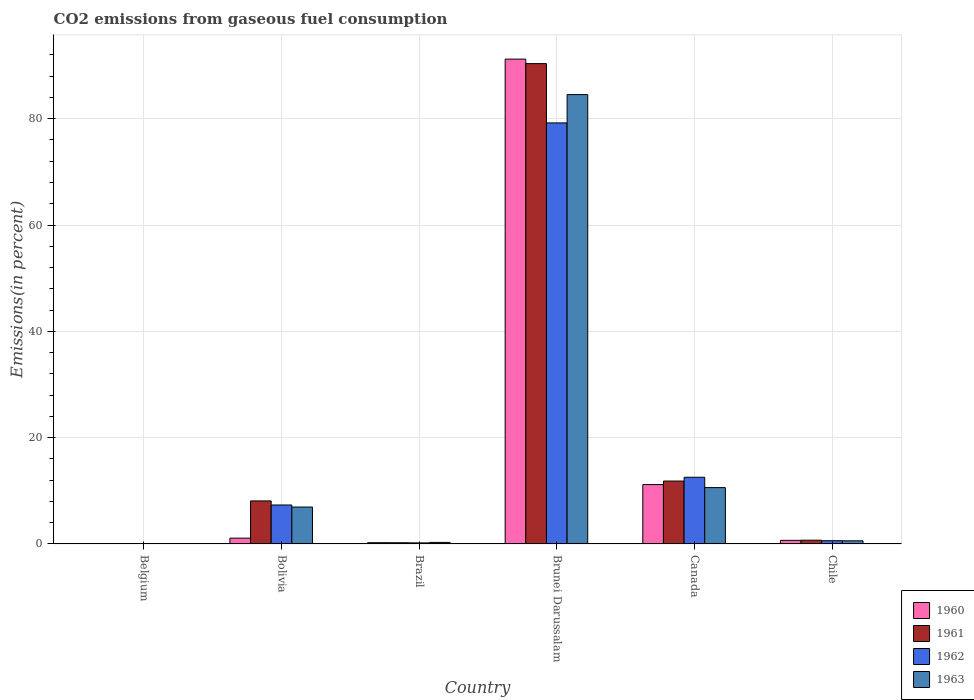Are the number of bars per tick equal to the number of legend labels?
Give a very brief answer. Yes. Are the number of bars on each tick of the X-axis equal?
Make the answer very short. Yes. How many bars are there on the 2nd tick from the left?
Provide a short and direct response. 4. What is the label of the 4th group of bars from the left?
Keep it short and to the point. Brunei Darussalam. What is the total CO2 emitted in 1963 in Belgium?
Keep it short and to the point. 0.07. Across all countries, what is the maximum total CO2 emitted in 1961?
Offer a very short reply. 90.36. Across all countries, what is the minimum total CO2 emitted in 1960?
Give a very brief answer. 0.07. In which country was the total CO2 emitted in 1960 maximum?
Provide a short and direct response. Brunei Darussalam. In which country was the total CO2 emitted in 1962 minimum?
Give a very brief answer. Belgium. What is the total total CO2 emitted in 1961 in the graph?
Make the answer very short. 111.31. What is the difference between the total CO2 emitted in 1961 in Bolivia and that in Canada?
Offer a very short reply. -3.74. What is the difference between the total CO2 emitted in 1961 in Bolivia and the total CO2 emitted in 1960 in Brazil?
Offer a very short reply. 7.86. What is the average total CO2 emitted in 1962 per country?
Your response must be concise. 16.66. What is the difference between the total CO2 emitted of/in 1963 and total CO2 emitted of/in 1961 in Canada?
Ensure brevity in your answer.  -1.23. What is the ratio of the total CO2 emitted in 1962 in Belgium to that in Brunei Darussalam?
Give a very brief answer. 0. Is the total CO2 emitted in 1960 in Bolivia less than that in Brunei Darussalam?
Make the answer very short. Yes. What is the difference between the highest and the second highest total CO2 emitted in 1962?
Provide a short and direct response. -5.22. What is the difference between the highest and the lowest total CO2 emitted in 1960?
Your response must be concise. 91.14. In how many countries, is the total CO2 emitted in 1963 greater than the average total CO2 emitted in 1963 taken over all countries?
Give a very brief answer. 1. What does the 3rd bar from the left in Bolivia represents?
Your answer should be compact. 1962. Is it the case that in every country, the sum of the total CO2 emitted in 1960 and total CO2 emitted in 1962 is greater than the total CO2 emitted in 1963?
Your answer should be very brief. Yes. How many bars are there?
Make the answer very short. 24. Are all the bars in the graph horizontal?
Offer a terse response. No. How many countries are there in the graph?
Provide a short and direct response. 6. What is the difference between two consecutive major ticks on the Y-axis?
Your response must be concise. 20. Are the values on the major ticks of Y-axis written in scientific E-notation?
Offer a terse response. No. Does the graph contain any zero values?
Give a very brief answer. No. What is the title of the graph?
Offer a terse response. CO2 emissions from gaseous fuel consumption. What is the label or title of the X-axis?
Keep it short and to the point. Country. What is the label or title of the Y-axis?
Offer a very short reply. Emissions(in percent). What is the Emissions(in percent) of 1960 in Belgium?
Your answer should be compact. 0.07. What is the Emissions(in percent) of 1961 in Belgium?
Offer a very short reply. 0.08. What is the Emissions(in percent) in 1962 in Belgium?
Your response must be concise. 0.08. What is the Emissions(in percent) of 1963 in Belgium?
Your response must be concise. 0.07. What is the Emissions(in percent) in 1960 in Bolivia?
Your response must be concise. 1.09. What is the Emissions(in percent) of 1961 in Bolivia?
Give a very brief answer. 8.1. What is the Emissions(in percent) in 1962 in Bolivia?
Offer a terse response. 7.33. What is the Emissions(in percent) in 1963 in Bolivia?
Provide a succinct answer. 6.95. What is the Emissions(in percent) in 1960 in Brazil?
Your answer should be very brief. 0.24. What is the Emissions(in percent) of 1961 in Brazil?
Your answer should be very brief. 0.23. What is the Emissions(in percent) of 1962 in Brazil?
Offer a terse response. 0.2. What is the Emissions(in percent) of 1963 in Brazil?
Make the answer very short. 0.3. What is the Emissions(in percent) in 1960 in Brunei Darussalam?
Your response must be concise. 91.21. What is the Emissions(in percent) of 1961 in Brunei Darussalam?
Your answer should be very brief. 90.36. What is the Emissions(in percent) in 1962 in Brunei Darussalam?
Provide a succinct answer. 79.21. What is the Emissions(in percent) in 1963 in Brunei Darussalam?
Keep it short and to the point. 84.54. What is the Emissions(in percent) in 1960 in Canada?
Offer a very short reply. 11.17. What is the Emissions(in percent) in 1961 in Canada?
Give a very brief answer. 11.84. What is the Emissions(in percent) of 1962 in Canada?
Offer a terse response. 12.55. What is the Emissions(in percent) of 1963 in Canada?
Your answer should be compact. 10.6. What is the Emissions(in percent) in 1960 in Chile?
Provide a succinct answer. 0.68. What is the Emissions(in percent) of 1961 in Chile?
Offer a terse response. 0.71. What is the Emissions(in percent) of 1962 in Chile?
Offer a terse response. 0.61. What is the Emissions(in percent) in 1963 in Chile?
Provide a succinct answer. 0.59. Across all countries, what is the maximum Emissions(in percent) of 1960?
Offer a very short reply. 91.21. Across all countries, what is the maximum Emissions(in percent) of 1961?
Provide a succinct answer. 90.36. Across all countries, what is the maximum Emissions(in percent) of 1962?
Your answer should be compact. 79.21. Across all countries, what is the maximum Emissions(in percent) of 1963?
Ensure brevity in your answer.  84.54. Across all countries, what is the minimum Emissions(in percent) in 1960?
Offer a terse response. 0.07. Across all countries, what is the minimum Emissions(in percent) of 1961?
Make the answer very short. 0.08. Across all countries, what is the minimum Emissions(in percent) of 1962?
Your answer should be very brief. 0.08. Across all countries, what is the minimum Emissions(in percent) in 1963?
Ensure brevity in your answer.  0.07. What is the total Emissions(in percent) in 1960 in the graph?
Keep it short and to the point. 104.47. What is the total Emissions(in percent) of 1961 in the graph?
Keep it short and to the point. 111.31. What is the total Emissions(in percent) of 1962 in the graph?
Your answer should be compact. 99.99. What is the total Emissions(in percent) in 1963 in the graph?
Keep it short and to the point. 103.04. What is the difference between the Emissions(in percent) in 1960 in Belgium and that in Bolivia?
Keep it short and to the point. -1.03. What is the difference between the Emissions(in percent) in 1961 in Belgium and that in Bolivia?
Offer a terse response. -8.02. What is the difference between the Emissions(in percent) of 1962 in Belgium and that in Bolivia?
Provide a succinct answer. -7.25. What is the difference between the Emissions(in percent) in 1963 in Belgium and that in Bolivia?
Offer a terse response. -6.88. What is the difference between the Emissions(in percent) in 1960 in Belgium and that in Brazil?
Ensure brevity in your answer.  -0.17. What is the difference between the Emissions(in percent) in 1961 in Belgium and that in Brazil?
Ensure brevity in your answer.  -0.16. What is the difference between the Emissions(in percent) in 1962 in Belgium and that in Brazil?
Make the answer very short. -0.13. What is the difference between the Emissions(in percent) in 1963 in Belgium and that in Brazil?
Offer a very short reply. -0.23. What is the difference between the Emissions(in percent) of 1960 in Belgium and that in Brunei Darussalam?
Provide a succinct answer. -91.14. What is the difference between the Emissions(in percent) of 1961 in Belgium and that in Brunei Darussalam?
Your answer should be very brief. -90.29. What is the difference between the Emissions(in percent) in 1962 in Belgium and that in Brunei Darussalam?
Provide a succinct answer. -79.13. What is the difference between the Emissions(in percent) in 1963 in Belgium and that in Brunei Darussalam?
Offer a terse response. -84.47. What is the difference between the Emissions(in percent) of 1960 in Belgium and that in Canada?
Offer a very short reply. -11.11. What is the difference between the Emissions(in percent) in 1961 in Belgium and that in Canada?
Your response must be concise. -11.76. What is the difference between the Emissions(in percent) of 1962 in Belgium and that in Canada?
Provide a succinct answer. -12.47. What is the difference between the Emissions(in percent) in 1963 in Belgium and that in Canada?
Give a very brief answer. -10.54. What is the difference between the Emissions(in percent) of 1960 in Belgium and that in Chile?
Provide a short and direct response. -0.61. What is the difference between the Emissions(in percent) of 1961 in Belgium and that in Chile?
Offer a very short reply. -0.63. What is the difference between the Emissions(in percent) of 1962 in Belgium and that in Chile?
Your response must be concise. -0.54. What is the difference between the Emissions(in percent) of 1963 in Belgium and that in Chile?
Your response must be concise. -0.53. What is the difference between the Emissions(in percent) in 1960 in Bolivia and that in Brazil?
Your answer should be compact. 0.85. What is the difference between the Emissions(in percent) of 1961 in Bolivia and that in Brazil?
Keep it short and to the point. 7.87. What is the difference between the Emissions(in percent) in 1962 in Bolivia and that in Brazil?
Provide a short and direct response. 7.13. What is the difference between the Emissions(in percent) of 1963 in Bolivia and that in Brazil?
Offer a terse response. 6.65. What is the difference between the Emissions(in percent) of 1960 in Bolivia and that in Brunei Darussalam?
Your response must be concise. -90.11. What is the difference between the Emissions(in percent) of 1961 in Bolivia and that in Brunei Darussalam?
Your answer should be compact. -82.26. What is the difference between the Emissions(in percent) in 1962 in Bolivia and that in Brunei Darussalam?
Make the answer very short. -71.87. What is the difference between the Emissions(in percent) of 1963 in Bolivia and that in Brunei Darussalam?
Your answer should be very brief. -77.59. What is the difference between the Emissions(in percent) in 1960 in Bolivia and that in Canada?
Offer a terse response. -10.08. What is the difference between the Emissions(in percent) of 1961 in Bolivia and that in Canada?
Make the answer very short. -3.74. What is the difference between the Emissions(in percent) of 1962 in Bolivia and that in Canada?
Your answer should be very brief. -5.22. What is the difference between the Emissions(in percent) of 1963 in Bolivia and that in Canada?
Make the answer very short. -3.65. What is the difference between the Emissions(in percent) in 1960 in Bolivia and that in Chile?
Ensure brevity in your answer.  0.42. What is the difference between the Emissions(in percent) of 1961 in Bolivia and that in Chile?
Offer a very short reply. 7.39. What is the difference between the Emissions(in percent) in 1962 in Bolivia and that in Chile?
Your answer should be compact. 6.72. What is the difference between the Emissions(in percent) of 1963 in Bolivia and that in Chile?
Your response must be concise. 6.36. What is the difference between the Emissions(in percent) of 1960 in Brazil and that in Brunei Darussalam?
Offer a very short reply. -90.97. What is the difference between the Emissions(in percent) of 1961 in Brazil and that in Brunei Darussalam?
Give a very brief answer. -90.13. What is the difference between the Emissions(in percent) in 1962 in Brazil and that in Brunei Darussalam?
Keep it short and to the point. -79. What is the difference between the Emissions(in percent) in 1963 in Brazil and that in Brunei Darussalam?
Your answer should be compact. -84.24. What is the difference between the Emissions(in percent) in 1960 in Brazil and that in Canada?
Provide a succinct answer. -10.93. What is the difference between the Emissions(in percent) of 1961 in Brazil and that in Canada?
Provide a succinct answer. -11.61. What is the difference between the Emissions(in percent) in 1962 in Brazil and that in Canada?
Offer a terse response. -12.34. What is the difference between the Emissions(in percent) in 1963 in Brazil and that in Canada?
Give a very brief answer. -10.31. What is the difference between the Emissions(in percent) in 1960 in Brazil and that in Chile?
Offer a very short reply. -0.44. What is the difference between the Emissions(in percent) of 1961 in Brazil and that in Chile?
Make the answer very short. -0.48. What is the difference between the Emissions(in percent) of 1962 in Brazil and that in Chile?
Your answer should be compact. -0.41. What is the difference between the Emissions(in percent) in 1963 in Brazil and that in Chile?
Ensure brevity in your answer.  -0.29. What is the difference between the Emissions(in percent) in 1960 in Brunei Darussalam and that in Canada?
Offer a terse response. 80.03. What is the difference between the Emissions(in percent) of 1961 in Brunei Darussalam and that in Canada?
Ensure brevity in your answer.  78.52. What is the difference between the Emissions(in percent) of 1962 in Brunei Darussalam and that in Canada?
Give a very brief answer. 66.66. What is the difference between the Emissions(in percent) of 1963 in Brunei Darussalam and that in Canada?
Make the answer very short. 73.93. What is the difference between the Emissions(in percent) of 1960 in Brunei Darussalam and that in Chile?
Provide a short and direct response. 90.53. What is the difference between the Emissions(in percent) of 1961 in Brunei Darussalam and that in Chile?
Provide a succinct answer. 89.65. What is the difference between the Emissions(in percent) of 1962 in Brunei Darussalam and that in Chile?
Keep it short and to the point. 78.59. What is the difference between the Emissions(in percent) of 1963 in Brunei Darussalam and that in Chile?
Offer a very short reply. 83.94. What is the difference between the Emissions(in percent) of 1960 in Canada and that in Chile?
Keep it short and to the point. 10.49. What is the difference between the Emissions(in percent) of 1961 in Canada and that in Chile?
Offer a terse response. 11.13. What is the difference between the Emissions(in percent) in 1962 in Canada and that in Chile?
Your response must be concise. 11.93. What is the difference between the Emissions(in percent) in 1963 in Canada and that in Chile?
Offer a terse response. 10.01. What is the difference between the Emissions(in percent) in 1960 in Belgium and the Emissions(in percent) in 1961 in Bolivia?
Offer a very short reply. -8.03. What is the difference between the Emissions(in percent) in 1960 in Belgium and the Emissions(in percent) in 1962 in Bolivia?
Make the answer very short. -7.26. What is the difference between the Emissions(in percent) of 1960 in Belgium and the Emissions(in percent) of 1963 in Bolivia?
Make the answer very short. -6.88. What is the difference between the Emissions(in percent) in 1961 in Belgium and the Emissions(in percent) in 1962 in Bolivia?
Give a very brief answer. -7.26. What is the difference between the Emissions(in percent) in 1961 in Belgium and the Emissions(in percent) in 1963 in Bolivia?
Your response must be concise. -6.87. What is the difference between the Emissions(in percent) in 1962 in Belgium and the Emissions(in percent) in 1963 in Bolivia?
Make the answer very short. -6.87. What is the difference between the Emissions(in percent) of 1960 in Belgium and the Emissions(in percent) of 1961 in Brazil?
Your answer should be very brief. -0.16. What is the difference between the Emissions(in percent) in 1960 in Belgium and the Emissions(in percent) in 1962 in Brazil?
Provide a short and direct response. -0.14. What is the difference between the Emissions(in percent) in 1960 in Belgium and the Emissions(in percent) in 1963 in Brazil?
Ensure brevity in your answer.  -0.23. What is the difference between the Emissions(in percent) of 1961 in Belgium and the Emissions(in percent) of 1962 in Brazil?
Provide a short and direct response. -0.13. What is the difference between the Emissions(in percent) of 1961 in Belgium and the Emissions(in percent) of 1963 in Brazil?
Offer a very short reply. -0.22. What is the difference between the Emissions(in percent) in 1962 in Belgium and the Emissions(in percent) in 1963 in Brazil?
Keep it short and to the point. -0.22. What is the difference between the Emissions(in percent) in 1960 in Belgium and the Emissions(in percent) in 1961 in Brunei Darussalam?
Provide a short and direct response. -90.29. What is the difference between the Emissions(in percent) of 1960 in Belgium and the Emissions(in percent) of 1962 in Brunei Darussalam?
Give a very brief answer. -79.14. What is the difference between the Emissions(in percent) in 1960 in Belgium and the Emissions(in percent) in 1963 in Brunei Darussalam?
Provide a short and direct response. -84.47. What is the difference between the Emissions(in percent) in 1961 in Belgium and the Emissions(in percent) in 1962 in Brunei Darussalam?
Ensure brevity in your answer.  -79.13. What is the difference between the Emissions(in percent) of 1961 in Belgium and the Emissions(in percent) of 1963 in Brunei Darussalam?
Provide a succinct answer. -84.46. What is the difference between the Emissions(in percent) in 1962 in Belgium and the Emissions(in percent) in 1963 in Brunei Darussalam?
Offer a terse response. -84.46. What is the difference between the Emissions(in percent) of 1960 in Belgium and the Emissions(in percent) of 1961 in Canada?
Keep it short and to the point. -11.77. What is the difference between the Emissions(in percent) of 1960 in Belgium and the Emissions(in percent) of 1962 in Canada?
Your answer should be compact. -12.48. What is the difference between the Emissions(in percent) of 1960 in Belgium and the Emissions(in percent) of 1963 in Canada?
Your response must be concise. -10.53. What is the difference between the Emissions(in percent) of 1961 in Belgium and the Emissions(in percent) of 1962 in Canada?
Offer a terse response. -12.47. What is the difference between the Emissions(in percent) in 1961 in Belgium and the Emissions(in percent) in 1963 in Canada?
Keep it short and to the point. -10.53. What is the difference between the Emissions(in percent) in 1962 in Belgium and the Emissions(in percent) in 1963 in Canada?
Give a very brief answer. -10.52. What is the difference between the Emissions(in percent) in 1960 in Belgium and the Emissions(in percent) in 1961 in Chile?
Ensure brevity in your answer.  -0.64. What is the difference between the Emissions(in percent) of 1960 in Belgium and the Emissions(in percent) of 1962 in Chile?
Offer a terse response. -0.55. What is the difference between the Emissions(in percent) of 1960 in Belgium and the Emissions(in percent) of 1963 in Chile?
Offer a very short reply. -0.52. What is the difference between the Emissions(in percent) in 1961 in Belgium and the Emissions(in percent) in 1962 in Chile?
Ensure brevity in your answer.  -0.54. What is the difference between the Emissions(in percent) of 1961 in Belgium and the Emissions(in percent) of 1963 in Chile?
Offer a terse response. -0.52. What is the difference between the Emissions(in percent) in 1962 in Belgium and the Emissions(in percent) in 1963 in Chile?
Keep it short and to the point. -0.51. What is the difference between the Emissions(in percent) of 1960 in Bolivia and the Emissions(in percent) of 1961 in Brazil?
Your answer should be compact. 0.86. What is the difference between the Emissions(in percent) in 1960 in Bolivia and the Emissions(in percent) in 1962 in Brazil?
Give a very brief answer. 0.89. What is the difference between the Emissions(in percent) in 1960 in Bolivia and the Emissions(in percent) in 1963 in Brazil?
Give a very brief answer. 0.8. What is the difference between the Emissions(in percent) of 1961 in Bolivia and the Emissions(in percent) of 1962 in Brazil?
Ensure brevity in your answer.  7.89. What is the difference between the Emissions(in percent) in 1961 in Bolivia and the Emissions(in percent) in 1963 in Brazil?
Ensure brevity in your answer.  7.8. What is the difference between the Emissions(in percent) in 1962 in Bolivia and the Emissions(in percent) in 1963 in Brazil?
Provide a succinct answer. 7.04. What is the difference between the Emissions(in percent) of 1960 in Bolivia and the Emissions(in percent) of 1961 in Brunei Darussalam?
Keep it short and to the point. -89.27. What is the difference between the Emissions(in percent) in 1960 in Bolivia and the Emissions(in percent) in 1962 in Brunei Darussalam?
Provide a succinct answer. -78.11. What is the difference between the Emissions(in percent) of 1960 in Bolivia and the Emissions(in percent) of 1963 in Brunei Darussalam?
Your answer should be very brief. -83.44. What is the difference between the Emissions(in percent) of 1961 in Bolivia and the Emissions(in percent) of 1962 in Brunei Darussalam?
Your response must be concise. -71.11. What is the difference between the Emissions(in percent) in 1961 in Bolivia and the Emissions(in percent) in 1963 in Brunei Darussalam?
Offer a very short reply. -76.44. What is the difference between the Emissions(in percent) of 1962 in Bolivia and the Emissions(in percent) of 1963 in Brunei Darussalam?
Your answer should be very brief. -77.2. What is the difference between the Emissions(in percent) in 1960 in Bolivia and the Emissions(in percent) in 1961 in Canada?
Your answer should be very brief. -10.74. What is the difference between the Emissions(in percent) of 1960 in Bolivia and the Emissions(in percent) of 1962 in Canada?
Make the answer very short. -11.45. What is the difference between the Emissions(in percent) in 1960 in Bolivia and the Emissions(in percent) in 1963 in Canada?
Provide a short and direct response. -9.51. What is the difference between the Emissions(in percent) of 1961 in Bolivia and the Emissions(in percent) of 1962 in Canada?
Your answer should be very brief. -4.45. What is the difference between the Emissions(in percent) in 1961 in Bolivia and the Emissions(in percent) in 1963 in Canada?
Offer a terse response. -2.5. What is the difference between the Emissions(in percent) in 1962 in Bolivia and the Emissions(in percent) in 1963 in Canada?
Keep it short and to the point. -3.27. What is the difference between the Emissions(in percent) of 1960 in Bolivia and the Emissions(in percent) of 1961 in Chile?
Give a very brief answer. 0.39. What is the difference between the Emissions(in percent) in 1960 in Bolivia and the Emissions(in percent) in 1962 in Chile?
Give a very brief answer. 0.48. What is the difference between the Emissions(in percent) of 1960 in Bolivia and the Emissions(in percent) of 1963 in Chile?
Ensure brevity in your answer.  0.5. What is the difference between the Emissions(in percent) in 1961 in Bolivia and the Emissions(in percent) in 1962 in Chile?
Keep it short and to the point. 7.48. What is the difference between the Emissions(in percent) in 1961 in Bolivia and the Emissions(in percent) in 1963 in Chile?
Your answer should be compact. 7.51. What is the difference between the Emissions(in percent) of 1962 in Bolivia and the Emissions(in percent) of 1963 in Chile?
Keep it short and to the point. 6.74. What is the difference between the Emissions(in percent) in 1960 in Brazil and the Emissions(in percent) in 1961 in Brunei Darussalam?
Your response must be concise. -90.12. What is the difference between the Emissions(in percent) of 1960 in Brazil and the Emissions(in percent) of 1962 in Brunei Darussalam?
Give a very brief answer. -78.97. What is the difference between the Emissions(in percent) in 1960 in Brazil and the Emissions(in percent) in 1963 in Brunei Darussalam?
Offer a very short reply. -84.29. What is the difference between the Emissions(in percent) of 1961 in Brazil and the Emissions(in percent) of 1962 in Brunei Darussalam?
Provide a short and direct response. -78.98. What is the difference between the Emissions(in percent) of 1961 in Brazil and the Emissions(in percent) of 1963 in Brunei Darussalam?
Your response must be concise. -84.31. What is the difference between the Emissions(in percent) in 1962 in Brazil and the Emissions(in percent) in 1963 in Brunei Darussalam?
Keep it short and to the point. -84.33. What is the difference between the Emissions(in percent) in 1960 in Brazil and the Emissions(in percent) in 1961 in Canada?
Your answer should be compact. -11.59. What is the difference between the Emissions(in percent) of 1960 in Brazil and the Emissions(in percent) of 1962 in Canada?
Provide a succinct answer. -12.31. What is the difference between the Emissions(in percent) of 1960 in Brazil and the Emissions(in percent) of 1963 in Canada?
Your response must be concise. -10.36. What is the difference between the Emissions(in percent) in 1961 in Brazil and the Emissions(in percent) in 1962 in Canada?
Your response must be concise. -12.32. What is the difference between the Emissions(in percent) in 1961 in Brazil and the Emissions(in percent) in 1963 in Canada?
Provide a short and direct response. -10.37. What is the difference between the Emissions(in percent) in 1962 in Brazil and the Emissions(in percent) in 1963 in Canada?
Your answer should be very brief. -10.4. What is the difference between the Emissions(in percent) in 1960 in Brazil and the Emissions(in percent) in 1961 in Chile?
Give a very brief answer. -0.47. What is the difference between the Emissions(in percent) of 1960 in Brazil and the Emissions(in percent) of 1962 in Chile?
Provide a succinct answer. -0.37. What is the difference between the Emissions(in percent) of 1960 in Brazil and the Emissions(in percent) of 1963 in Chile?
Provide a succinct answer. -0.35. What is the difference between the Emissions(in percent) in 1961 in Brazil and the Emissions(in percent) in 1962 in Chile?
Make the answer very short. -0.38. What is the difference between the Emissions(in percent) in 1961 in Brazil and the Emissions(in percent) in 1963 in Chile?
Your response must be concise. -0.36. What is the difference between the Emissions(in percent) in 1962 in Brazil and the Emissions(in percent) in 1963 in Chile?
Keep it short and to the point. -0.39. What is the difference between the Emissions(in percent) in 1960 in Brunei Darussalam and the Emissions(in percent) in 1961 in Canada?
Provide a short and direct response. 79.37. What is the difference between the Emissions(in percent) in 1960 in Brunei Darussalam and the Emissions(in percent) in 1962 in Canada?
Your response must be concise. 78.66. What is the difference between the Emissions(in percent) of 1960 in Brunei Darussalam and the Emissions(in percent) of 1963 in Canada?
Offer a terse response. 80.61. What is the difference between the Emissions(in percent) of 1961 in Brunei Darussalam and the Emissions(in percent) of 1962 in Canada?
Offer a very short reply. 77.81. What is the difference between the Emissions(in percent) in 1961 in Brunei Darussalam and the Emissions(in percent) in 1963 in Canada?
Provide a succinct answer. 79.76. What is the difference between the Emissions(in percent) of 1962 in Brunei Darussalam and the Emissions(in percent) of 1963 in Canada?
Keep it short and to the point. 68.61. What is the difference between the Emissions(in percent) of 1960 in Brunei Darussalam and the Emissions(in percent) of 1961 in Chile?
Offer a terse response. 90.5. What is the difference between the Emissions(in percent) in 1960 in Brunei Darussalam and the Emissions(in percent) in 1962 in Chile?
Offer a very short reply. 90.59. What is the difference between the Emissions(in percent) in 1960 in Brunei Darussalam and the Emissions(in percent) in 1963 in Chile?
Your answer should be very brief. 90.62. What is the difference between the Emissions(in percent) of 1961 in Brunei Darussalam and the Emissions(in percent) of 1962 in Chile?
Your response must be concise. 89.75. What is the difference between the Emissions(in percent) in 1961 in Brunei Darussalam and the Emissions(in percent) in 1963 in Chile?
Ensure brevity in your answer.  89.77. What is the difference between the Emissions(in percent) in 1962 in Brunei Darussalam and the Emissions(in percent) in 1963 in Chile?
Offer a very short reply. 78.62. What is the difference between the Emissions(in percent) in 1960 in Canada and the Emissions(in percent) in 1961 in Chile?
Provide a short and direct response. 10.46. What is the difference between the Emissions(in percent) in 1960 in Canada and the Emissions(in percent) in 1962 in Chile?
Keep it short and to the point. 10.56. What is the difference between the Emissions(in percent) of 1960 in Canada and the Emissions(in percent) of 1963 in Chile?
Offer a very short reply. 10.58. What is the difference between the Emissions(in percent) in 1961 in Canada and the Emissions(in percent) in 1962 in Chile?
Your answer should be compact. 11.22. What is the difference between the Emissions(in percent) in 1961 in Canada and the Emissions(in percent) in 1963 in Chile?
Your answer should be compact. 11.25. What is the difference between the Emissions(in percent) in 1962 in Canada and the Emissions(in percent) in 1963 in Chile?
Make the answer very short. 11.96. What is the average Emissions(in percent) in 1960 per country?
Your response must be concise. 17.41. What is the average Emissions(in percent) in 1961 per country?
Provide a short and direct response. 18.55. What is the average Emissions(in percent) of 1962 per country?
Make the answer very short. 16.66. What is the average Emissions(in percent) in 1963 per country?
Offer a terse response. 17.17. What is the difference between the Emissions(in percent) of 1960 and Emissions(in percent) of 1961 in Belgium?
Offer a terse response. -0.01. What is the difference between the Emissions(in percent) of 1960 and Emissions(in percent) of 1962 in Belgium?
Offer a very short reply. -0.01. What is the difference between the Emissions(in percent) of 1960 and Emissions(in percent) of 1963 in Belgium?
Provide a short and direct response. 0. What is the difference between the Emissions(in percent) of 1961 and Emissions(in percent) of 1962 in Belgium?
Your answer should be compact. -0. What is the difference between the Emissions(in percent) in 1961 and Emissions(in percent) in 1963 in Belgium?
Ensure brevity in your answer.  0.01. What is the difference between the Emissions(in percent) of 1962 and Emissions(in percent) of 1963 in Belgium?
Your answer should be compact. 0.01. What is the difference between the Emissions(in percent) in 1960 and Emissions(in percent) in 1961 in Bolivia?
Give a very brief answer. -7. What is the difference between the Emissions(in percent) of 1960 and Emissions(in percent) of 1962 in Bolivia?
Make the answer very short. -6.24. What is the difference between the Emissions(in percent) of 1960 and Emissions(in percent) of 1963 in Bolivia?
Keep it short and to the point. -5.85. What is the difference between the Emissions(in percent) of 1961 and Emissions(in percent) of 1962 in Bolivia?
Provide a short and direct response. 0.77. What is the difference between the Emissions(in percent) of 1961 and Emissions(in percent) of 1963 in Bolivia?
Provide a short and direct response. 1.15. What is the difference between the Emissions(in percent) of 1962 and Emissions(in percent) of 1963 in Bolivia?
Offer a terse response. 0.38. What is the difference between the Emissions(in percent) in 1960 and Emissions(in percent) in 1961 in Brazil?
Offer a very short reply. 0.01. What is the difference between the Emissions(in percent) of 1960 and Emissions(in percent) of 1962 in Brazil?
Make the answer very short. 0.04. What is the difference between the Emissions(in percent) in 1960 and Emissions(in percent) in 1963 in Brazil?
Give a very brief answer. -0.05. What is the difference between the Emissions(in percent) of 1961 and Emissions(in percent) of 1962 in Brazil?
Your answer should be very brief. 0.03. What is the difference between the Emissions(in percent) of 1961 and Emissions(in percent) of 1963 in Brazil?
Ensure brevity in your answer.  -0.07. What is the difference between the Emissions(in percent) of 1962 and Emissions(in percent) of 1963 in Brazil?
Provide a short and direct response. -0.09. What is the difference between the Emissions(in percent) in 1960 and Emissions(in percent) in 1961 in Brunei Darussalam?
Give a very brief answer. 0.85. What is the difference between the Emissions(in percent) in 1960 and Emissions(in percent) in 1962 in Brunei Darussalam?
Provide a succinct answer. 12. What is the difference between the Emissions(in percent) in 1960 and Emissions(in percent) in 1963 in Brunei Darussalam?
Give a very brief answer. 6.67. What is the difference between the Emissions(in percent) in 1961 and Emissions(in percent) in 1962 in Brunei Darussalam?
Your answer should be very brief. 11.15. What is the difference between the Emissions(in percent) of 1961 and Emissions(in percent) of 1963 in Brunei Darussalam?
Make the answer very short. 5.83. What is the difference between the Emissions(in percent) of 1962 and Emissions(in percent) of 1963 in Brunei Darussalam?
Make the answer very short. -5.33. What is the difference between the Emissions(in percent) in 1960 and Emissions(in percent) in 1961 in Canada?
Offer a very short reply. -0.66. What is the difference between the Emissions(in percent) of 1960 and Emissions(in percent) of 1962 in Canada?
Your answer should be compact. -1.37. What is the difference between the Emissions(in percent) in 1960 and Emissions(in percent) in 1963 in Canada?
Your response must be concise. 0.57. What is the difference between the Emissions(in percent) in 1961 and Emissions(in percent) in 1962 in Canada?
Keep it short and to the point. -0.71. What is the difference between the Emissions(in percent) of 1961 and Emissions(in percent) of 1963 in Canada?
Give a very brief answer. 1.23. What is the difference between the Emissions(in percent) in 1962 and Emissions(in percent) in 1963 in Canada?
Provide a short and direct response. 1.95. What is the difference between the Emissions(in percent) in 1960 and Emissions(in percent) in 1961 in Chile?
Your answer should be compact. -0.03. What is the difference between the Emissions(in percent) in 1960 and Emissions(in percent) in 1962 in Chile?
Your answer should be compact. 0.07. What is the difference between the Emissions(in percent) in 1960 and Emissions(in percent) in 1963 in Chile?
Your answer should be compact. 0.09. What is the difference between the Emissions(in percent) in 1961 and Emissions(in percent) in 1962 in Chile?
Offer a terse response. 0.1. What is the difference between the Emissions(in percent) in 1961 and Emissions(in percent) in 1963 in Chile?
Your answer should be compact. 0.12. What is the difference between the Emissions(in percent) in 1962 and Emissions(in percent) in 1963 in Chile?
Keep it short and to the point. 0.02. What is the ratio of the Emissions(in percent) in 1960 in Belgium to that in Bolivia?
Keep it short and to the point. 0.06. What is the ratio of the Emissions(in percent) in 1961 in Belgium to that in Bolivia?
Your response must be concise. 0.01. What is the ratio of the Emissions(in percent) of 1962 in Belgium to that in Bolivia?
Your answer should be compact. 0.01. What is the ratio of the Emissions(in percent) of 1963 in Belgium to that in Bolivia?
Your answer should be compact. 0.01. What is the ratio of the Emissions(in percent) in 1960 in Belgium to that in Brazil?
Your answer should be very brief. 0.28. What is the ratio of the Emissions(in percent) of 1961 in Belgium to that in Brazil?
Provide a short and direct response. 0.33. What is the ratio of the Emissions(in percent) in 1962 in Belgium to that in Brazil?
Your answer should be very brief. 0.38. What is the ratio of the Emissions(in percent) in 1963 in Belgium to that in Brazil?
Give a very brief answer. 0.22. What is the ratio of the Emissions(in percent) in 1960 in Belgium to that in Brunei Darussalam?
Your answer should be very brief. 0. What is the ratio of the Emissions(in percent) in 1961 in Belgium to that in Brunei Darussalam?
Your answer should be compact. 0. What is the ratio of the Emissions(in percent) in 1962 in Belgium to that in Brunei Darussalam?
Ensure brevity in your answer.  0. What is the ratio of the Emissions(in percent) in 1963 in Belgium to that in Brunei Darussalam?
Offer a terse response. 0. What is the ratio of the Emissions(in percent) of 1960 in Belgium to that in Canada?
Your answer should be compact. 0.01. What is the ratio of the Emissions(in percent) of 1961 in Belgium to that in Canada?
Ensure brevity in your answer.  0.01. What is the ratio of the Emissions(in percent) in 1962 in Belgium to that in Canada?
Your answer should be compact. 0.01. What is the ratio of the Emissions(in percent) of 1963 in Belgium to that in Canada?
Keep it short and to the point. 0.01. What is the ratio of the Emissions(in percent) in 1960 in Belgium to that in Chile?
Ensure brevity in your answer.  0.1. What is the ratio of the Emissions(in percent) in 1961 in Belgium to that in Chile?
Offer a very short reply. 0.11. What is the ratio of the Emissions(in percent) of 1962 in Belgium to that in Chile?
Offer a terse response. 0.13. What is the ratio of the Emissions(in percent) of 1963 in Belgium to that in Chile?
Make the answer very short. 0.11. What is the ratio of the Emissions(in percent) of 1960 in Bolivia to that in Brazil?
Offer a very short reply. 4.52. What is the ratio of the Emissions(in percent) of 1961 in Bolivia to that in Brazil?
Your answer should be very brief. 35.05. What is the ratio of the Emissions(in percent) in 1962 in Bolivia to that in Brazil?
Give a very brief answer. 35.79. What is the ratio of the Emissions(in percent) of 1963 in Bolivia to that in Brazil?
Your answer should be compact. 23.42. What is the ratio of the Emissions(in percent) in 1960 in Bolivia to that in Brunei Darussalam?
Your answer should be compact. 0.01. What is the ratio of the Emissions(in percent) in 1961 in Bolivia to that in Brunei Darussalam?
Provide a short and direct response. 0.09. What is the ratio of the Emissions(in percent) in 1962 in Bolivia to that in Brunei Darussalam?
Provide a short and direct response. 0.09. What is the ratio of the Emissions(in percent) of 1963 in Bolivia to that in Brunei Darussalam?
Offer a very short reply. 0.08. What is the ratio of the Emissions(in percent) in 1960 in Bolivia to that in Canada?
Offer a terse response. 0.1. What is the ratio of the Emissions(in percent) in 1961 in Bolivia to that in Canada?
Your answer should be compact. 0.68. What is the ratio of the Emissions(in percent) of 1962 in Bolivia to that in Canada?
Provide a short and direct response. 0.58. What is the ratio of the Emissions(in percent) in 1963 in Bolivia to that in Canada?
Your answer should be compact. 0.66. What is the ratio of the Emissions(in percent) in 1960 in Bolivia to that in Chile?
Offer a very short reply. 1.61. What is the ratio of the Emissions(in percent) in 1961 in Bolivia to that in Chile?
Your answer should be very brief. 11.42. What is the ratio of the Emissions(in percent) of 1962 in Bolivia to that in Chile?
Keep it short and to the point. 11.95. What is the ratio of the Emissions(in percent) of 1963 in Bolivia to that in Chile?
Make the answer very short. 11.75. What is the ratio of the Emissions(in percent) of 1960 in Brazil to that in Brunei Darussalam?
Keep it short and to the point. 0. What is the ratio of the Emissions(in percent) in 1961 in Brazil to that in Brunei Darussalam?
Make the answer very short. 0. What is the ratio of the Emissions(in percent) of 1962 in Brazil to that in Brunei Darussalam?
Make the answer very short. 0. What is the ratio of the Emissions(in percent) of 1963 in Brazil to that in Brunei Darussalam?
Provide a succinct answer. 0. What is the ratio of the Emissions(in percent) in 1960 in Brazil to that in Canada?
Your response must be concise. 0.02. What is the ratio of the Emissions(in percent) of 1961 in Brazil to that in Canada?
Your answer should be very brief. 0.02. What is the ratio of the Emissions(in percent) in 1962 in Brazil to that in Canada?
Offer a very short reply. 0.02. What is the ratio of the Emissions(in percent) in 1963 in Brazil to that in Canada?
Offer a very short reply. 0.03. What is the ratio of the Emissions(in percent) in 1960 in Brazil to that in Chile?
Make the answer very short. 0.36. What is the ratio of the Emissions(in percent) in 1961 in Brazil to that in Chile?
Ensure brevity in your answer.  0.33. What is the ratio of the Emissions(in percent) in 1962 in Brazil to that in Chile?
Provide a succinct answer. 0.33. What is the ratio of the Emissions(in percent) of 1963 in Brazil to that in Chile?
Keep it short and to the point. 0.5. What is the ratio of the Emissions(in percent) in 1960 in Brunei Darussalam to that in Canada?
Give a very brief answer. 8.16. What is the ratio of the Emissions(in percent) of 1961 in Brunei Darussalam to that in Canada?
Make the answer very short. 7.63. What is the ratio of the Emissions(in percent) in 1962 in Brunei Darussalam to that in Canada?
Offer a very short reply. 6.31. What is the ratio of the Emissions(in percent) in 1963 in Brunei Darussalam to that in Canada?
Give a very brief answer. 7.97. What is the ratio of the Emissions(in percent) in 1960 in Brunei Darussalam to that in Chile?
Offer a very short reply. 134.22. What is the ratio of the Emissions(in percent) in 1961 in Brunei Darussalam to that in Chile?
Provide a succinct answer. 127.38. What is the ratio of the Emissions(in percent) in 1962 in Brunei Darussalam to that in Chile?
Provide a short and direct response. 129.02. What is the ratio of the Emissions(in percent) of 1963 in Brunei Darussalam to that in Chile?
Make the answer very short. 142.9. What is the ratio of the Emissions(in percent) of 1960 in Canada to that in Chile?
Your response must be concise. 16.44. What is the ratio of the Emissions(in percent) in 1961 in Canada to that in Chile?
Your response must be concise. 16.69. What is the ratio of the Emissions(in percent) in 1962 in Canada to that in Chile?
Your answer should be compact. 20.44. What is the ratio of the Emissions(in percent) in 1963 in Canada to that in Chile?
Provide a succinct answer. 17.92. What is the difference between the highest and the second highest Emissions(in percent) in 1960?
Offer a very short reply. 80.03. What is the difference between the highest and the second highest Emissions(in percent) of 1961?
Keep it short and to the point. 78.52. What is the difference between the highest and the second highest Emissions(in percent) in 1962?
Provide a short and direct response. 66.66. What is the difference between the highest and the second highest Emissions(in percent) in 1963?
Offer a terse response. 73.93. What is the difference between the highest and the lowest Emissions(in percent) of 1960?
Give a very brief answer. 91.14. What is the difference between the highest and the lowest Emissions(in percent) of 1961?
Ensure brevity in your answer.  90.29. What is the difference between the highest and the lowest Emissions(in percent) of 1962?
Offer a very short reply. 79.13. What is the difference between the highest and the lowest Emissions(in percent) in 1963?
Provide a succinct answer. 84.47. 